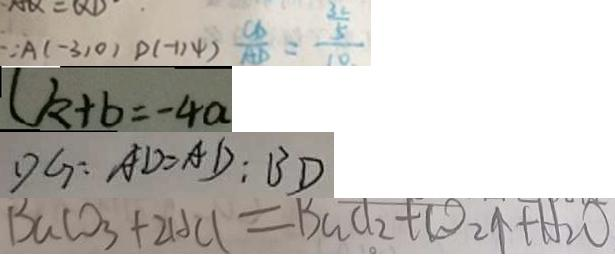Convert formula to latex. <formula><loc_0><loc_0><loc_500><loc_500>\because A ( - 3 , 0 ) D ( - 1 , 4 ) \frac { C D } { A D } = \frac { \frac { 3 2 } { 5 } } { 1 0 } 
 ( k + b = - 4 a 
 D G : A D = A D : B D 
 B a C O _ { 3 } + 2 H C l = B a C l _ { 2 } + C O _ { 2 } \uparrow + H _ { 2 } O</formula> 